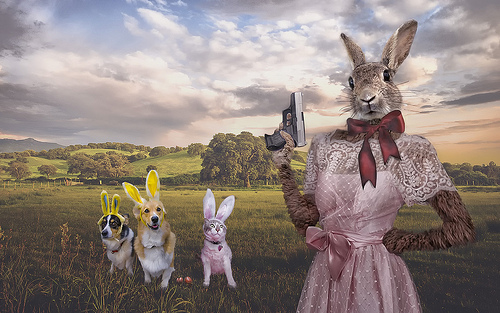<image>
Can you confirm if the dog is to the left of the dog? Yes. From this viewpoint, the dog is positioned to the left side relative to the dog. Where is the hand gun in relation to the sky? Is it under the sky? Yes. The hand gun is positioned underneath the sky, with the sky above it in the vertical space. 